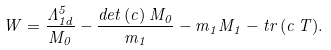Convert formula to latex. <formula><loc_0><loc_0><loc_500><loc_500>W = \frac { \Lambda _ { 1 d } ^ { 5 } } { M _ { 0 } } - \frac { d e t \, ( c ) \, M _ { 0 } } { m _ { 1 } } - m _ { 1 } M _ { 1 } - t r \, ( c \, T ) .</formula> 